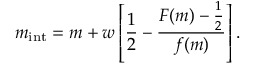<formula> <loc_0><loc_0><loc_500><loc_500>m _ { i n t } = m + w \left [ { \frac { 1 } { 2 } } - { \frac { F ( m ) - { \frac { 1 } { 2 } } } { f ( m ) } } \right ] .</formula> 